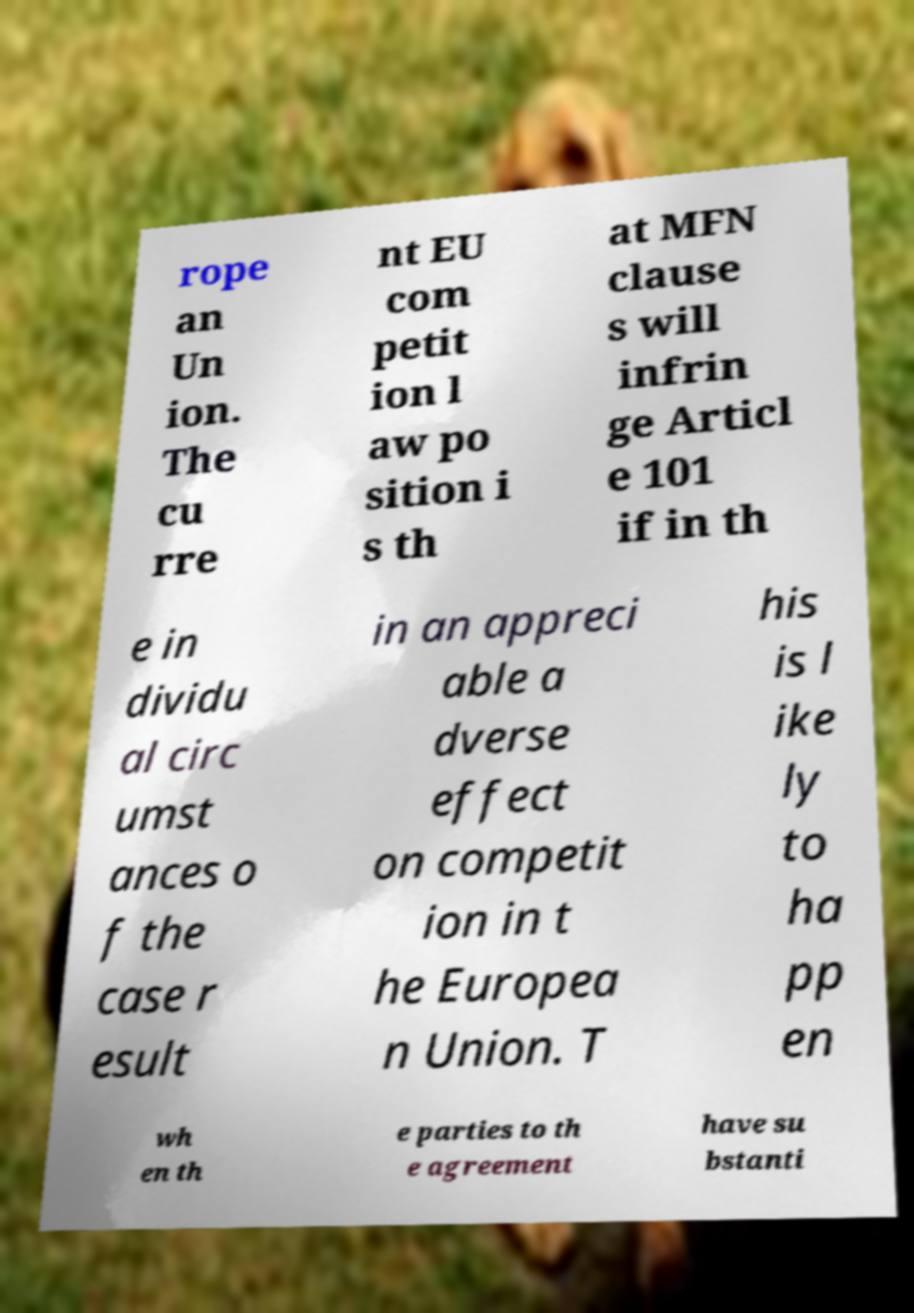Could you assist in decoding the text presented in this image and type it out clearly? rope an Un ion. The cu rre nt EU com petit ion l aw po sition i s th at MFN clause s will infrin ge Articl e 101 if in th e in dividu al circ umst ances o f the case r esult in an appreci able a dverse effect on competit ion in t he Europea n Union. T his is l ike ly to ha pp en wh en th e parties to th e agreement have su bstanti 